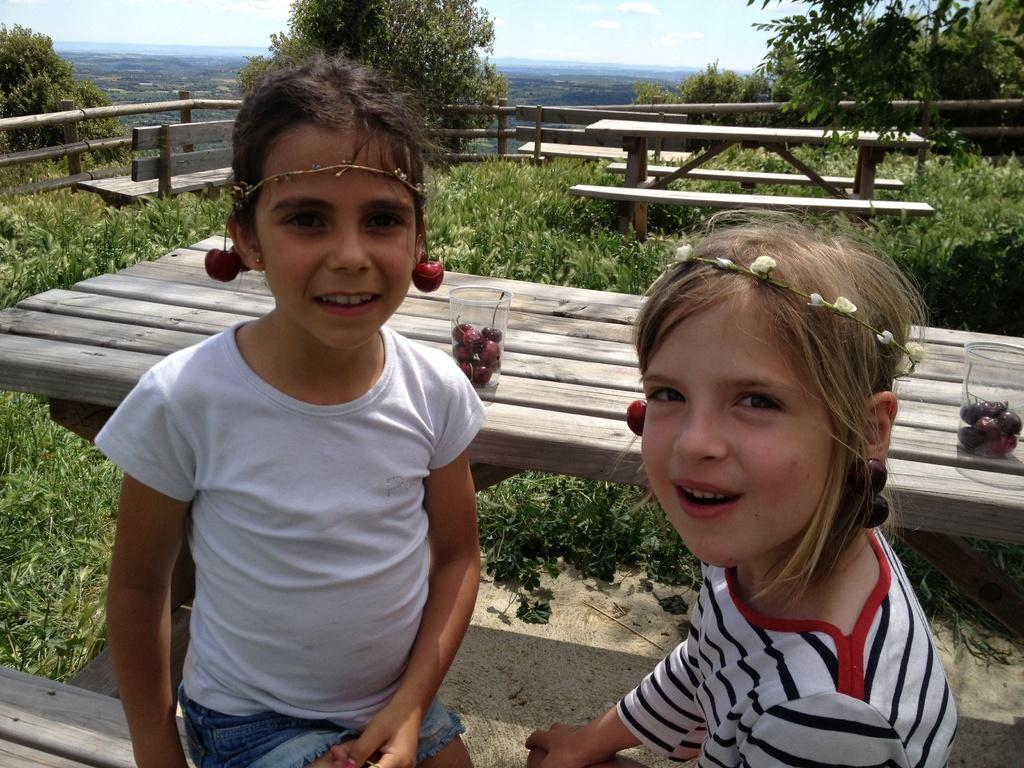How many children are sitting on the bench in the image? There are two children sitting on a bench in the image. What is on the table in the image? There is a table with objects on it in the image. What type of natural elements can be seen in the image? There are trees in the image. What architectural feature is present in the image? There is a fence in the image. What type of friction can be observed between the children and the bench in the image? There is no indication of friction between the children and the bench in the image. What pets are present with the children in the image? There are no pets visible in the image; only the two children, the bench, the table, the trees, and the fence can be seen. 